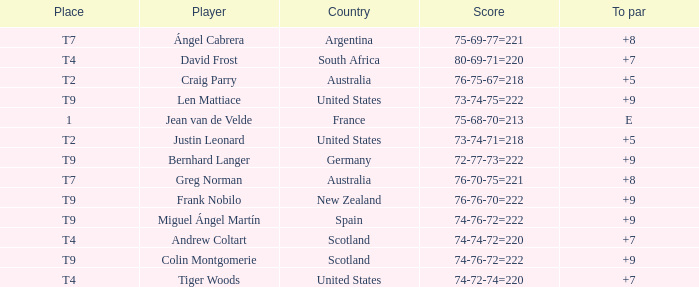Player Craig Parry of Australia is in what place number? T2. Would you be able to parse every entry in this table? {'header': ['Place', 'Player', 'Country', 'Score', 'To par'], 'rows': [['T7', 'Ángel Cabrera', 'Argentina', '75-69-77=221', '+8'], ['T4', 'David Frost', 'South Africa', '80-69-71=220', '+7'], ['T2', 'Craig Parry', 'Australia', '76-75-67=218', '+5'], ['T9', 'Len Mattiace', 'United States', '73-74-75=222', '+9'], ['1', 'Jean van de Velde', 'France', '75-68-70=213', 'E'], ['T2', 'Justin Leonard', 'United States', '73-74-71=218', '+5'], ['T9', 'Bernhard Langer', 'Germany', '72-77-73=222', '+9'], ['T7', 'Greg Norman', 'Australia', '76-70-75=221', '+8'], ['T9', 'Frank Nobilo', 'New Zealand', '76-76-70=222', '+9'], ['T9', 'Miguel Ángel Martín', 'Spain', '74-76-72=222', '+9'], ['T4', 'Andrew Coltart', 'Scotland', '74-74-72=220', '+7'], ['T9', 'Colin Montgomerie', 'Scotland', '74-76-72=222', '+9'], ['T4', 'Tiger Woods', 'United States', '74-72-74=220', '+7']]} 